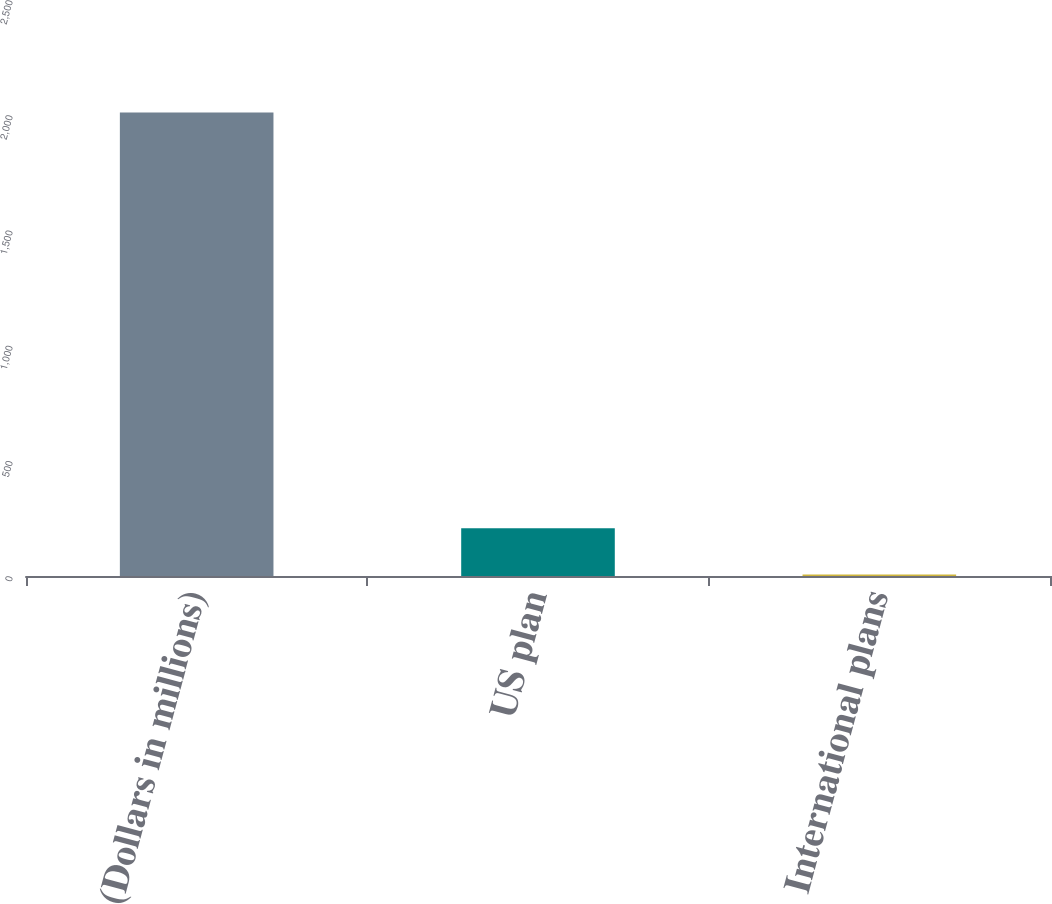Convert chart. <chart><loc_0><loc_0><loc_500><loc_500><bar_chart><fcel>(Dollars in millions)<fcel>US plan<fcel>International plans<nl><fcel>2012<fcel>207.5<fcel>7<nl></chart> 